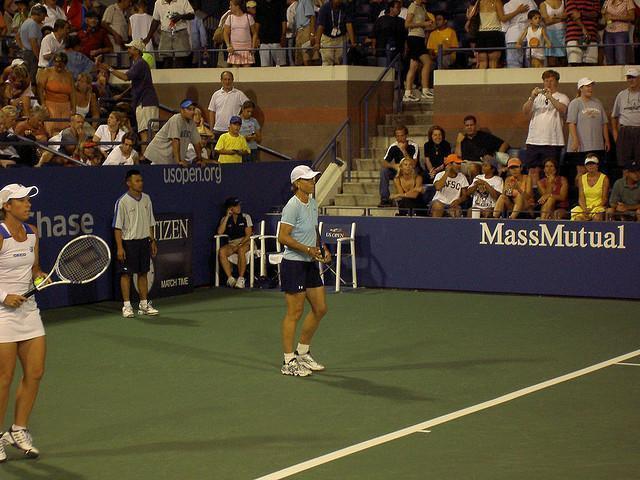How many people are there?
Give a very brief answer. 8. How many windows on this airplane are touched by red or orange paint?
Give a very brief answer. 0. 